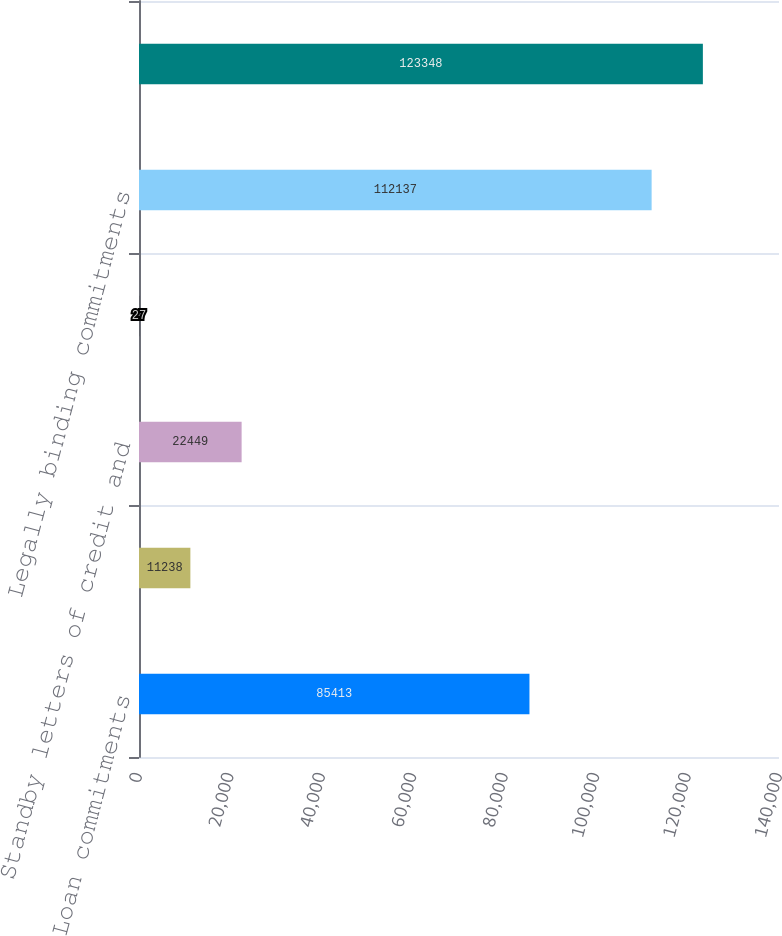Convert chart to OTSL. <chart><loc_0><loc_0><loc_500><loc_500><bar_chart><fcel>Loan commitments<fcel>Home equity lines of credit<fcel>Standby letters of credit and<fcel>Letters of credit<fcel>Legally binding commitments<fcel>Total credit extension<nl><fcel>85413<fcel>11238<fcel>22449<fcel>27<fcel>112137<fcel>123348<nl></chart> 